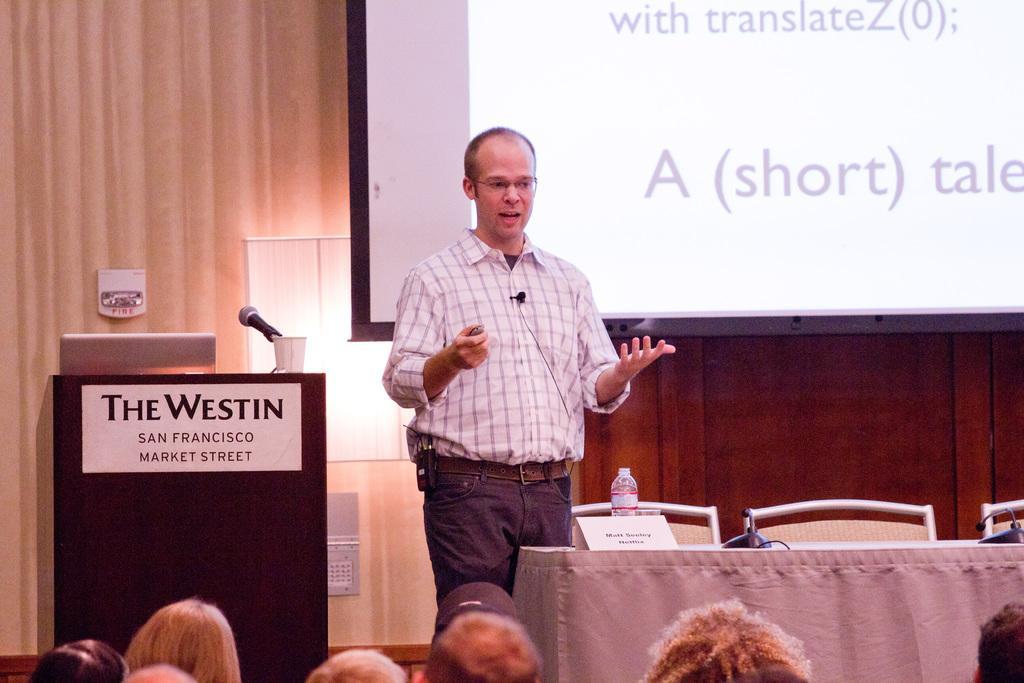Describe this image in one or two sentences. In this image there is a man standing. There is a microphone to his shirt. In front of him there is a table. On the table there are microphones, a bottle and a name board. Beside the table there are chairs. Beside the man there is a podium. There is text on the podium. On the podium there are glasses, a microphone and a laptop. In the background there is a wall. There is light on the wall. There is a projector board hanging on the wall. There is text on the board. At the bottom there are heads of the people. 